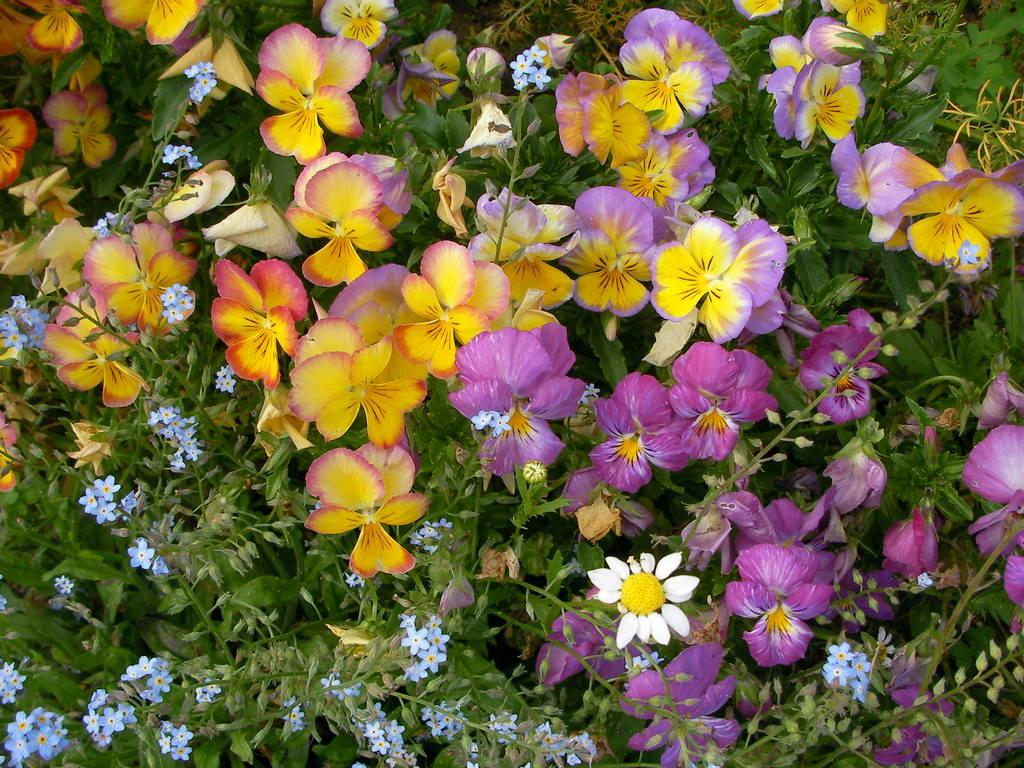What type of vegetation can be seen in the image? There are trees in the image. What is special about the trees in the image? The trees have flowers. What colors can be seen in the flowers? The flowers are in purple, yellow, blue, and white colors. Where can you find the store that sells these flowers in the image? There is no store present in the image; it only shows trees with flowers. 